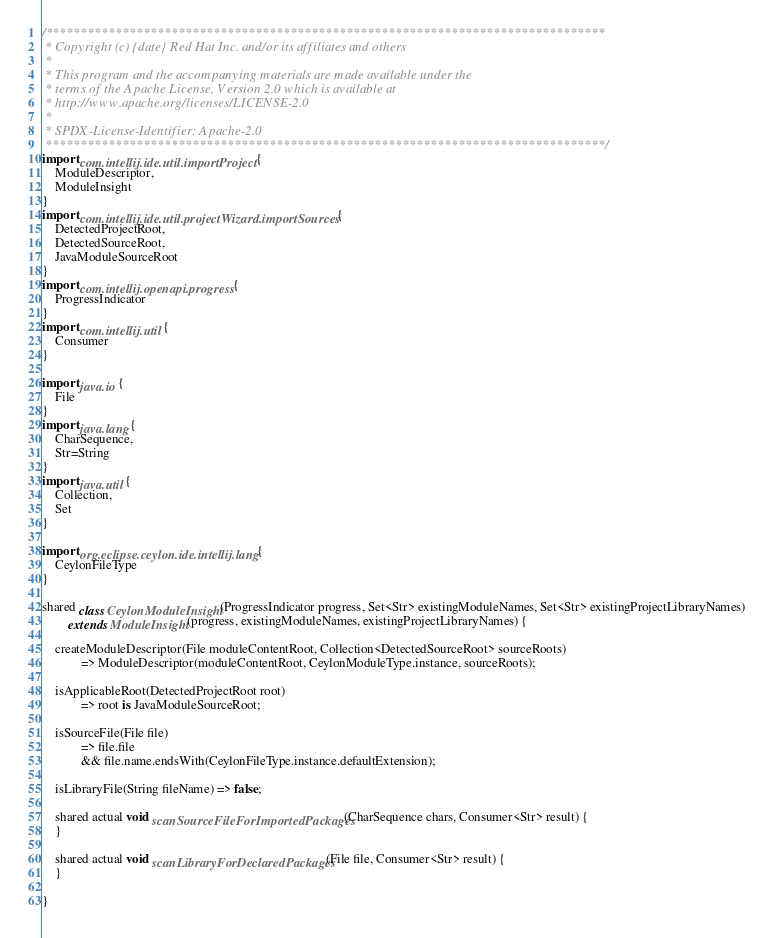<code> <loc_0><loc_0><loc_500><loc_500><_Ceylon_>/********************************************************************************
 * Copyright (c) {date} Red Hat Inc. and/or its affiliates and others
 *
 * This program and the accompanying materials are made available under the 
 * terms of the Apache License, Version 2.0 which is available at
 * http://www.apache.org/licenses/LICENSE-2.0
 *
 * SPDX-License-Identifier: Apache-2.0 
 ********************************************************************************/
import com.intellij.ide.util.importProject {
    ModuleDescriptor,
    ModuleInsight
}
import com.intellij.ide.util.projectWizard.importSources {
    DetectedProjectRoot,
    DetectedSourceRoot,
    JavaModuleSourceRoot
}
import com.intellij.openapi.progress {
    ProgressIndicator
}
import com.intellij.util {
    Consumer
}

import java.io {
    File
}
import java.lang {
    CharSequence,
    Str=String
}
import java.util {
    Collection,
    Set
}

import org.eclipse.ceylon.ide.intellij.lang {
    CeylonFileType
}

shared class CeylonModuleInsight(ProgressIndicator progress, Set<Str> existingModuleNames, Set<Str> existingProjectLibraryNames)
        extends ModuleInsight(progress, existingModuleNames, existingProjectLibraryNames) {

    createModuleDescriptor(File moduleContentRoot, Collection<DetectedSourceRoot> sourceRoots)
            => ModuleDescriptor(moduleContentRoot, CeylonModuleType.instance, sourceRoots);

    isApplicableRoot(DetectedProjectRoot root)
            => root is JavaModuleSourceRoot;

    isSourceFile(File file)
            => file.file
            && file.name.endsWith(CeylonFileType.instance.defaultExtension);

    isLibraryFile(String fileName) => false;

    shared actual void scanSourceFileForImportedPackages(CharSequence chars, Consumer<Str> result) {
    }

    shared actual void scanLibraryForDeclaredPackages(File file, Consumer<Str> result) {
    }

}
</code> 